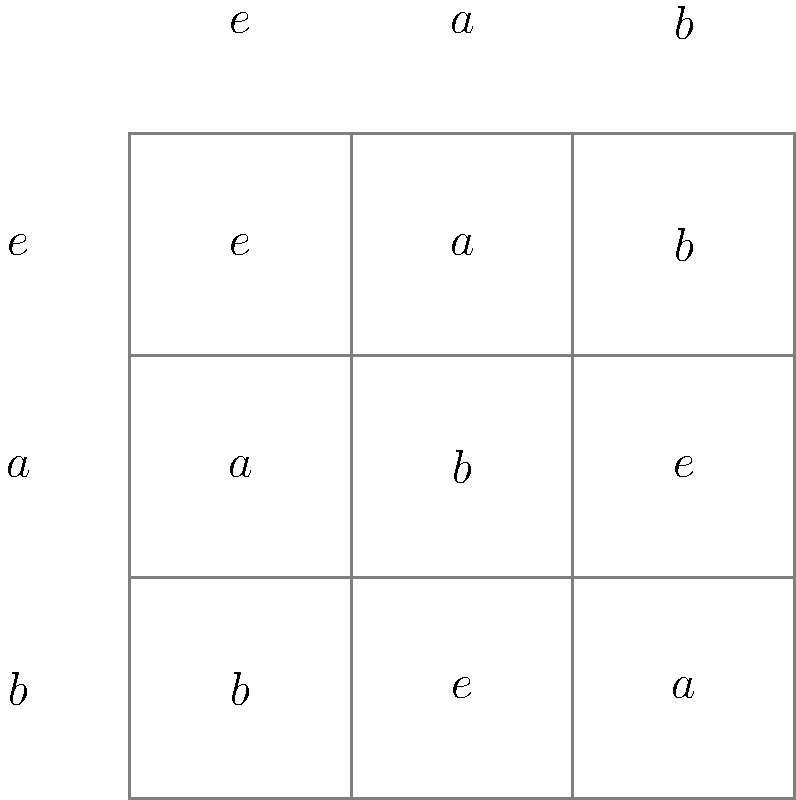Given the Cayley table for a finite group $G = \{e, a, b\}$, where $e$ is the identity element, determine the order of element $a$ and express it in cycle notation. To solve this problem, we need to follow these steps:

1. Understand the Cayley table:
   - The rows and columns represent the elements of the group.
   - The entries show the result of multiplying the row element by the column element.

2. Find the order of element $a$:
   - The order of an element is the smallest positive integer $n$ such that $a^n = e$.
   - From the table, we can see that $a \cdot a = b$ and $a \cdot b = e$.
   - This means $a^2 = b$ and $a^3 = e$.
   - Therefore, the order of $a$ is 3.

3. Express $a$ in cycle notation:
   - Cycle notation shows how the element permutes the elements of the group.
   - Start with $e$: $a(e) = a$
   - Then $a(a) = b$ (from the table)
   - Finally, $a(b) = e$ (from the table)
   - This completes the cycle: $(e \, a \, b)$

Therefore, in cycle notation, $a = (e \, a \, b)$, which is a 3-cycle, confirming that the order of $a$ is 3.
Answer: Order: 3; Cycle notation: $(e \, a \, b)$ 